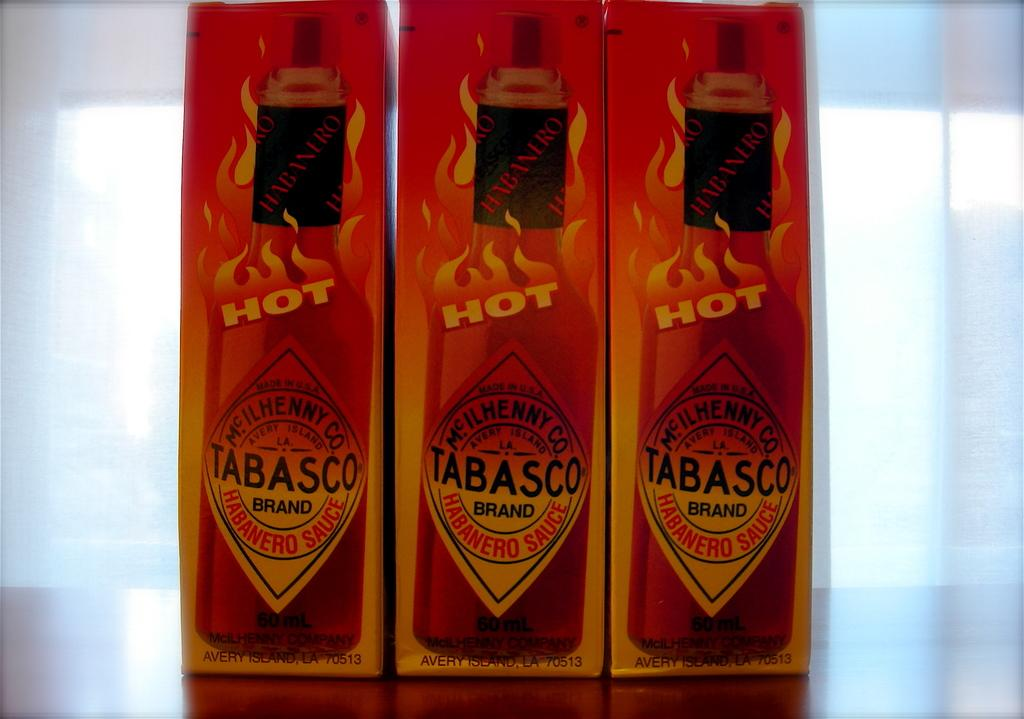Provide a one-sentence caption for the provided image. Three boxes of Tabasco sauce are lined up on a surface. 